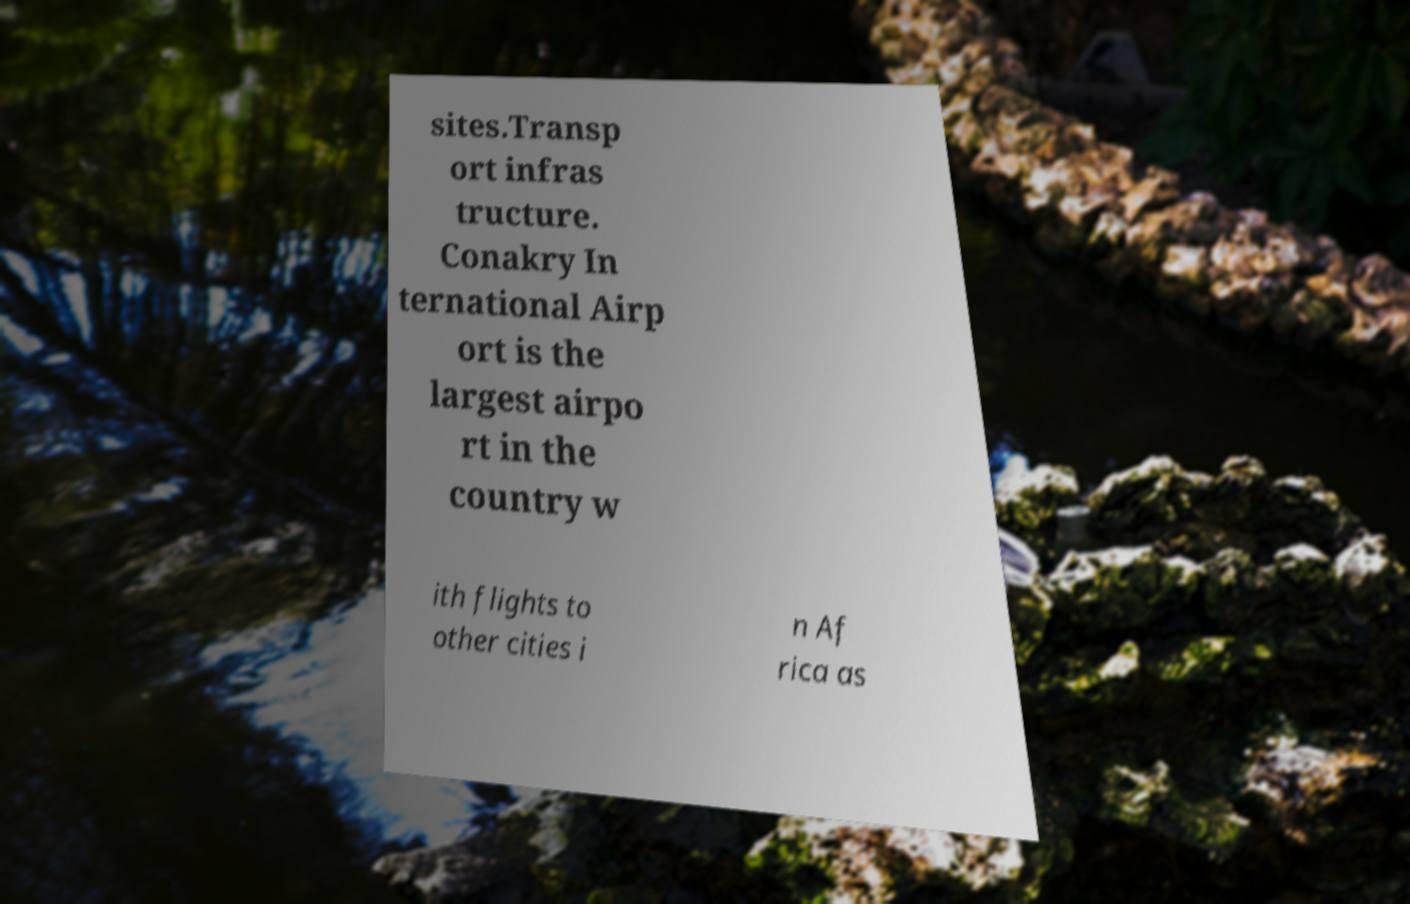I need the written content from this picture converted into text. Can you do that? sites.Transp ort infras tructure. Conakry In ternational Airp ort is the largest airpo rt in the country w ith flights to other cities i n Af rica as 